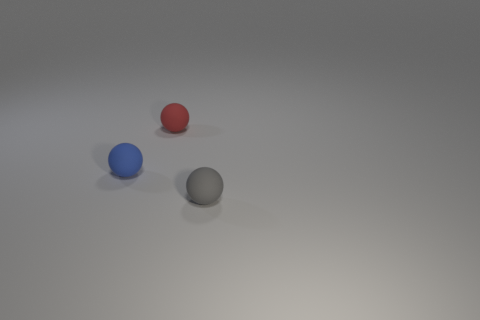Subtract all blue rubber spheres. How many spheres are left? 2 Add 1 tiny red rubber spheres. How many objects exist? 4 Subtract 2 spheres. How many spheres are left? 1 Subtract all red spheres. How many spheres are left? 2 Subtract all blue spheres. Subtract all red matte objects. How many objects are left? 1 Add 3 gray things. How many gray things are left? 4 Add 2 tiny gray balls. How many tiny gray balls exist? 3 Subtract 0 purple cubes. How many objects are left? 3 Subtract all green balls. Subtract all cyan cylinders. How many balls are left? 3 Subtract all green cubes. How many blue balls are left? 1 